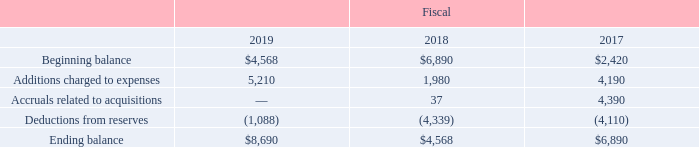Accounts Receivable Allowances
Accounts receivable allowances reflect our best estimate of probable losses inherent in our accounts receivable balances, including both losses for uncollectible accounts receivable and sales returns. We regularly review allowances by considering factors such as historical experience, credit quality, the age of the accounts receivable balances and current economic conditions that may affect a customer’s ability to pay.
Activity in accounts receivable allowance is as follows (in thousands):
What do Accounts receivable allowances reflect? Reflect our best estimate of probable losses inherent in our accounts receivable balances, including both losses for uncollectible accounts receivable and sales returns. What was the Ending balance in 2019?
Answer scale should be: thousand. $8,690. In which years were the accounts receivable allowances provided in the table? 2019, 2018, 2017. In which year were the Additions charged to expenses the largest? 5,210>4,190>1,980
Answer: 2019. What was the change in Ending balance in 2019 from 2018?
Answer scale should be: thousand. 8,690-4,568
Answer: 4122. What was the percentage change in Ending balance in 2019 from 2018?
Answer scale should be: percent. (8,690-4,568)/4,568
Answer: 90.24. 